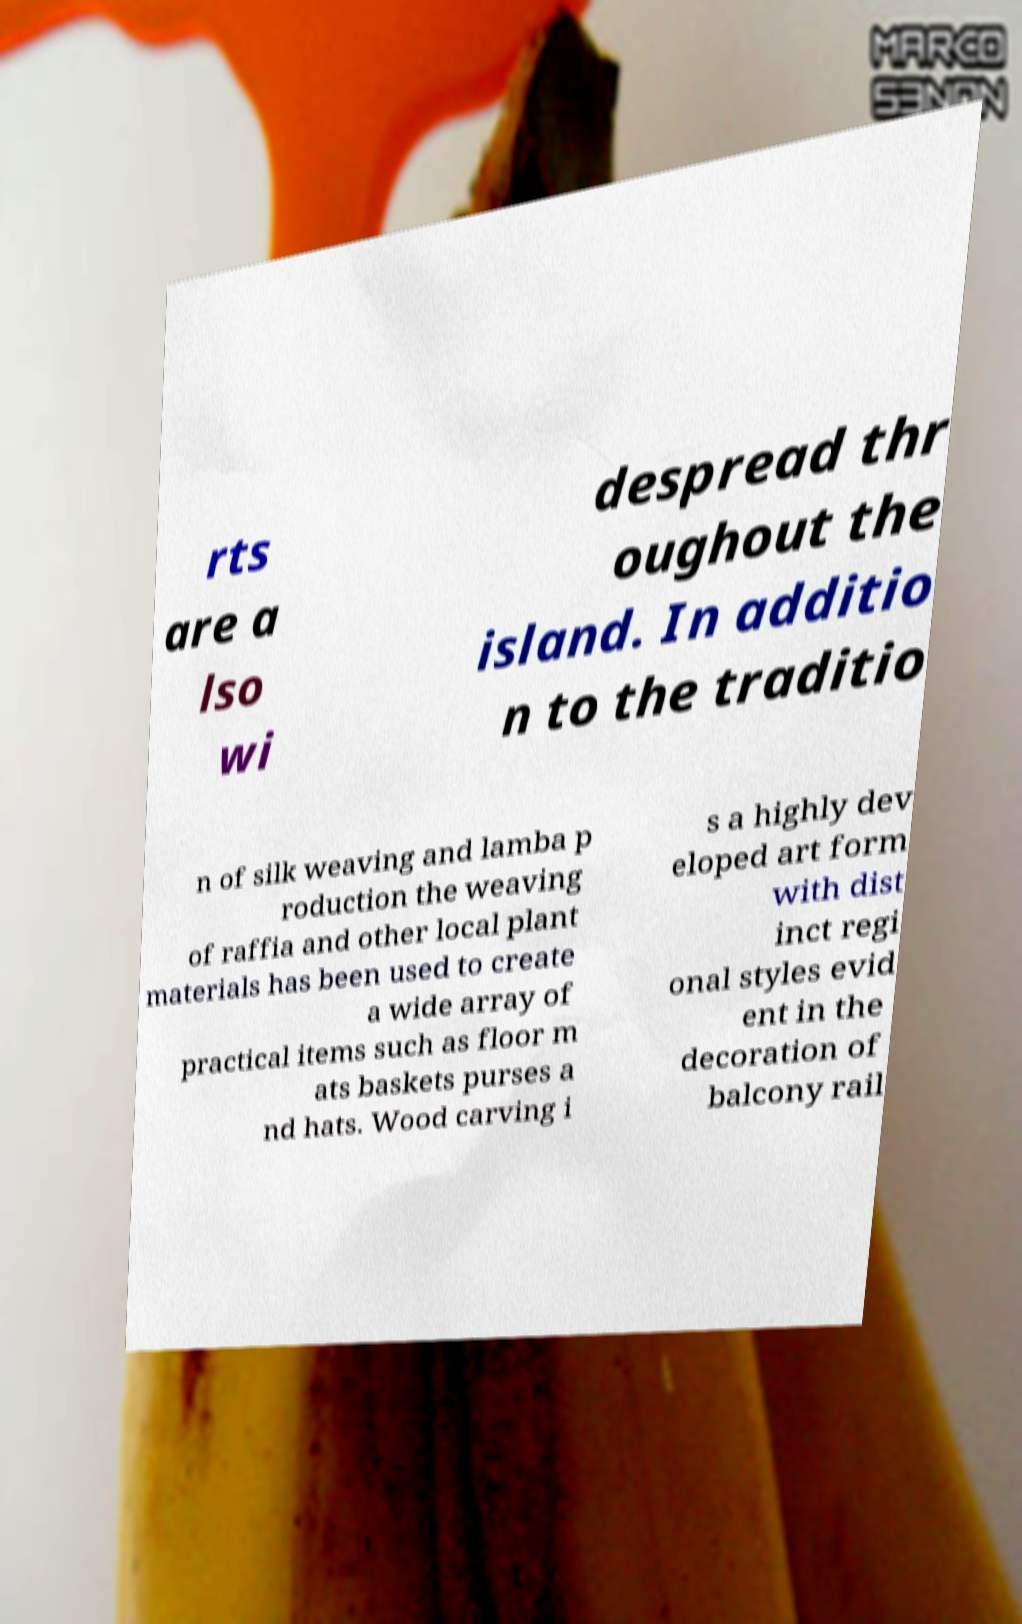For documentation purposes, I need the text within this image transcribed. Could you provide that? rts are a lso wi despread thr oughout the island. In additio n to the traditio n of silk weaving and lamba p roduction the weaving of raffia and other local plant materials has been used to create a wide array of practical items such as floor m ats baskets purses a nd hats. Wood carving i s a highly dev eloped art form with dist inct regi onal styles evid ent in the decoration of balcony rail 